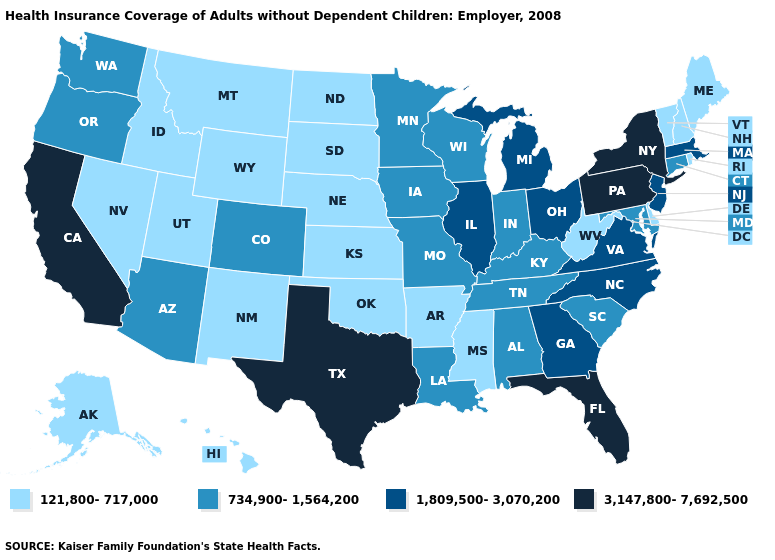Name the states that have a value in the range 1,809,500-3,070,200?
Give a very brief answer. Georgia, Illinois, Massachusetts, Michigan, New Jersey, North Carolina, Ohio, Virginia. Name the states that have a value in the range 3,147,800-7,692,500?
Keep it brief. California, Florida, New York, Pennsylvania, Texas. Does South Carolina have the same value as Wisconsin?
Write a very short answer. Yes. What is the value of West Virginia?
Answer briefly. 121,800-717,000. Does South Carolina have the lowest value in the USA?
Be succinct. No. Does Georgia have the lowest value in the South?
Concise answer only. No. Name the states that have a value in the range 3,147,800-7,692,500?
Write a very short answer. California, Florida, New York, Pennsylvania, Texas. What is the value of Washington?
Short answer required. 734,900-1,564,200. Does the map have missing data?
Answer briefly. No. Does South Dakota have the lowest value in the USA?
Keep it brief. Yes. What is the value of Wisconsin?
Quick response, please. 734,900-1,564,200. Name the states that have a value in the range 1,809,500-3,070,200?
Write a very short answer. Georgia, Illinois, Massachusetts, Michigan, New Jersey, North Carolina, Ohio, Virginia. Name the states that have a value in the range 3,147,800-7,692,500?
Give a very brief answer. California, Florida, New York, Pennsylvania, Texas. Does Rhode Island have the highest value in the USA?
Write a very short answer. No. Name the states that have a value in the range 1,809,500-3,070,200?
Write a very short answer. Georgia, Illinois, Massachusetts, Michigan, New Jersey, North Carolina, Ohio, Virginia. 